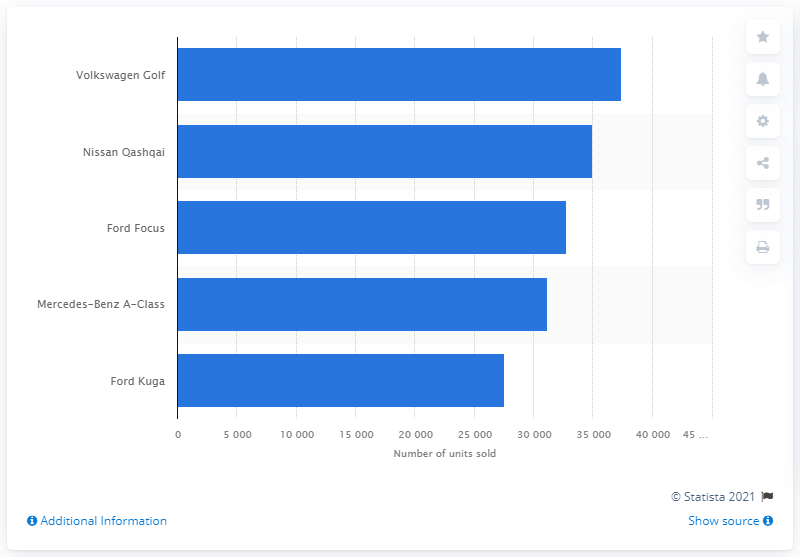Outline some significant characteristics in this image. In 2019, the Volkswagen Golf was the most popular model among consumers. 